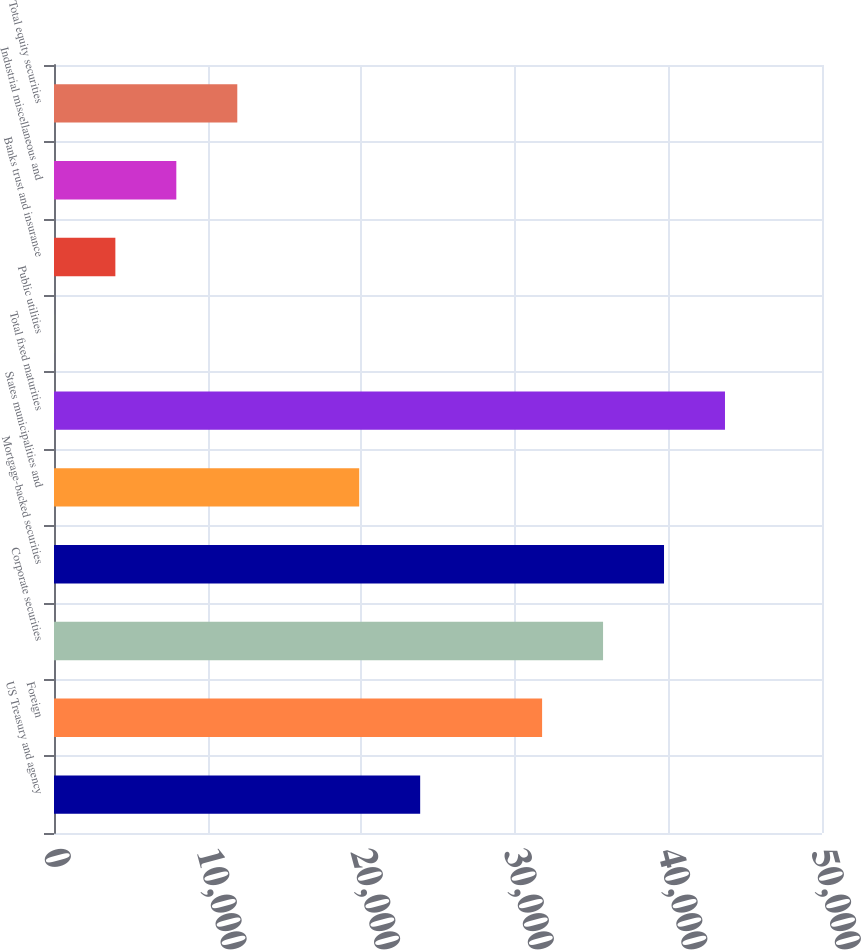Convert chart. <chart><loc_0><loc_0><loc_500><loc_500><bar_chart><fcel>US Treasury and agency<fcel>Foreign<fcel>Corporate securities<fcel>Mortgage-backed securities<fcel>States municipalities and<fcel>Total fixed maturities<fcel>Public utilities<fcel>Banks trust and insurance<fcel>Industrial miscellaneous and<fcel>Total equity securities<nl><fcel>23839.4<fcel>31777.2<fcel>35746.1<fcel>39715<fcel>19870.5<fcel>43683.9<fcel>26<fcel>3994.9<fcel>7963.8<fcel>11932.7<nl></chart> 